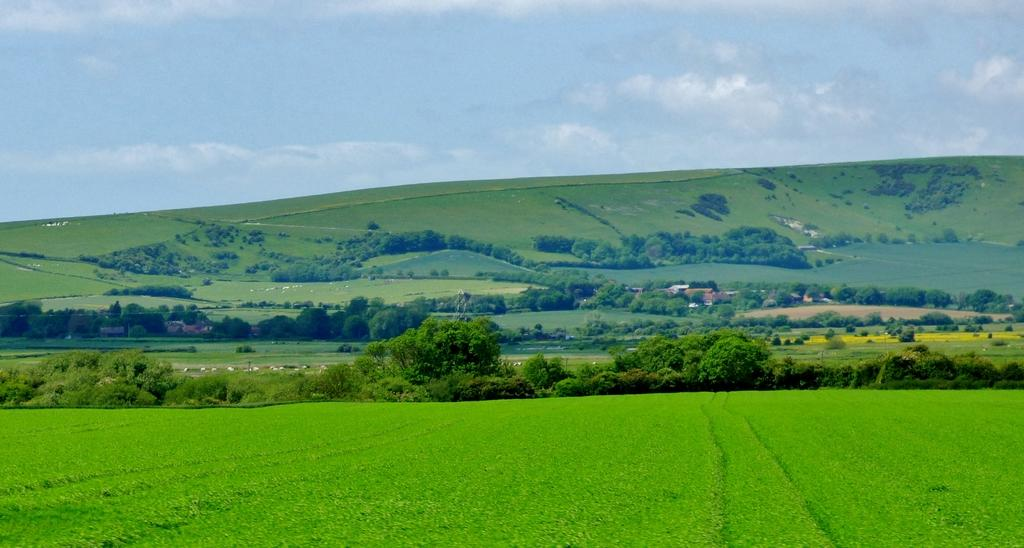What type of vegetation can be seen in the foreground of the image? There is greenery in the foreground of the image. What can be seen in the background of the image? There are trees and buildings in the background of the image. How is the slope surface characterized in the image? The slope surface has greenery. What part of the natural environment is visible in the image? The sky is visible in the image. What is the condition of the sky in the image? The sky has clouds in it. Can you tell me how many iron supports are visible in the image? There is no mention of iron supports in the image; the focus is on greenery, trees, buildings, and the sky. Is there a seashore visible in the image? There is no mention of a seashore in the image; the focus is on the greenery, trees, buildings, and the sky. 